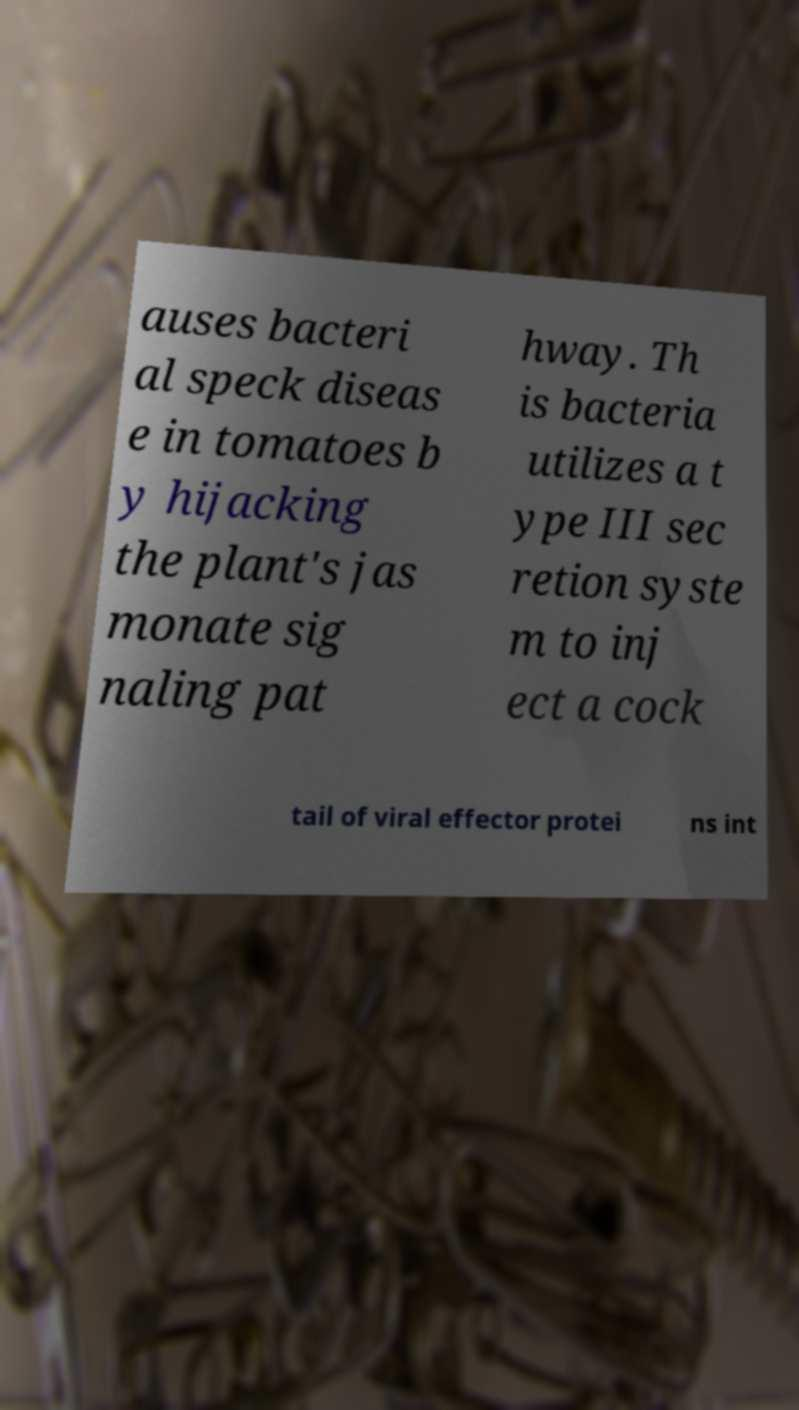Please read and relay the text visible in this image. What does it say? auses bacteri al speck diseas e in tomatoes b y hijacking the plant's jas monate sig naling pat hway. Th is bacteria utilizes a t ype III sec retion syste m to inj ect a cock tail of viral effector protei ns int 